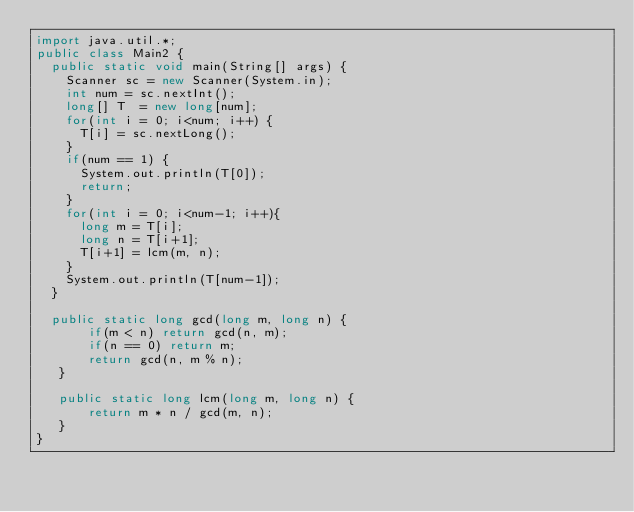<code> <loc_0><loc_0><loc_500><loc_500><_Java_>import java.util.*;
public class Main2 {
  public static void main(String[] args) {
    Scanner sc = new Scanner(System.in);
    int num = sc.nextInt();
    long[] T  = new long[num];
    for(int i = 0; i<num; i++) {
      T[i] = sc.nextLong();
    }
    if(num == 1) {
      System.out.println(T[0]);
      return;
    }
    for(int i = 0; i<num-1; i++){
      long m = T[i];
      long n = T[i+1];
      T[i+1] = lcm(m, n);
    }
    System.out.println(T[num-1]);
  }

  public static long gcd(long m, long n) {
       if(m < n) return gcd(n, m);
       if(n == 0) return m;
       return gcd(n, m % n);
   }

   public static long lcm(long m, long n) {
       return m * n / gcd(m, n);
   }
}
</code> 